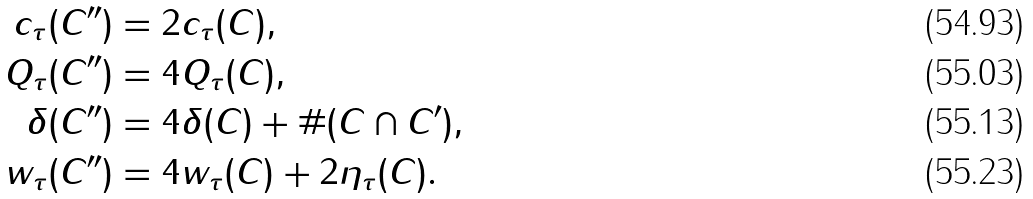Convert formula to latex. <formula><loc_0><loc_0><loc_500><loc_500>c _ { \tau } ( C ^ { \prime \prime } ) & = 2 c _ { \tau } ( C ) , \\ Q _ { \tau } ( C ^ { \prime \prime } ) & = 4 Q _ { \tau } ( C ) , \\ \delta ( C ^ { \prime \prime } ) & = 4 \delta ( C ) + \# ( C \cap C ^ { \prime } ) , \\ w _ { \tau } ( C ^ { \prime \prime } ) & = 4 w _ { \tau } ( C ) + 2 \eta _ { \tau } ( C ) .</formula> 